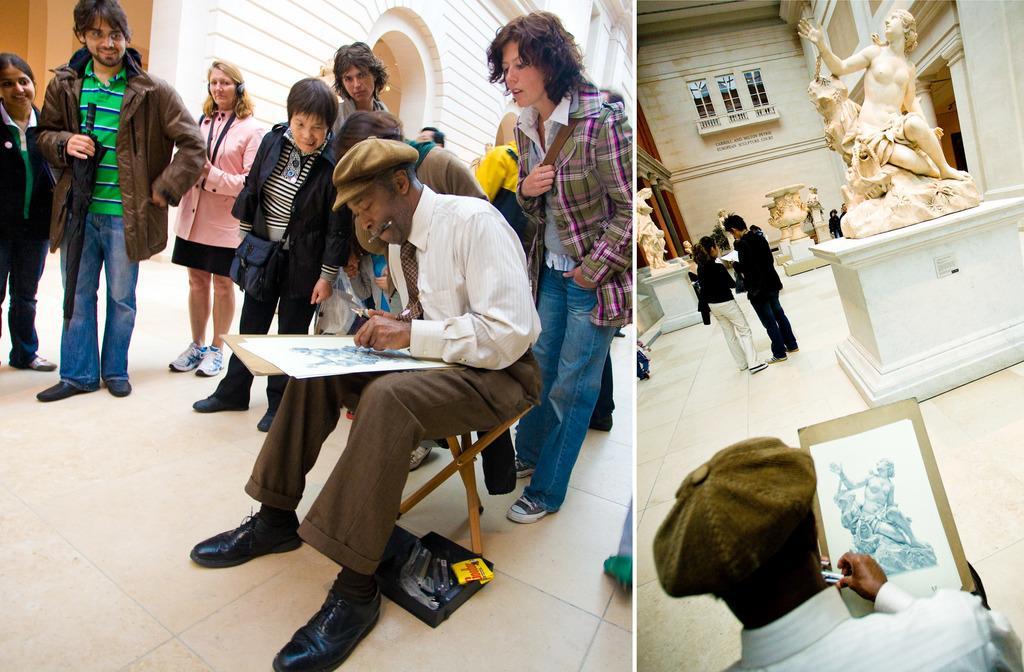Can you describe this image briefly? This image consists of many people. It is edited and made as a collage. To the right, there is a man sketching the statue. At the bottom, there is a floor. It looks like a museum. 